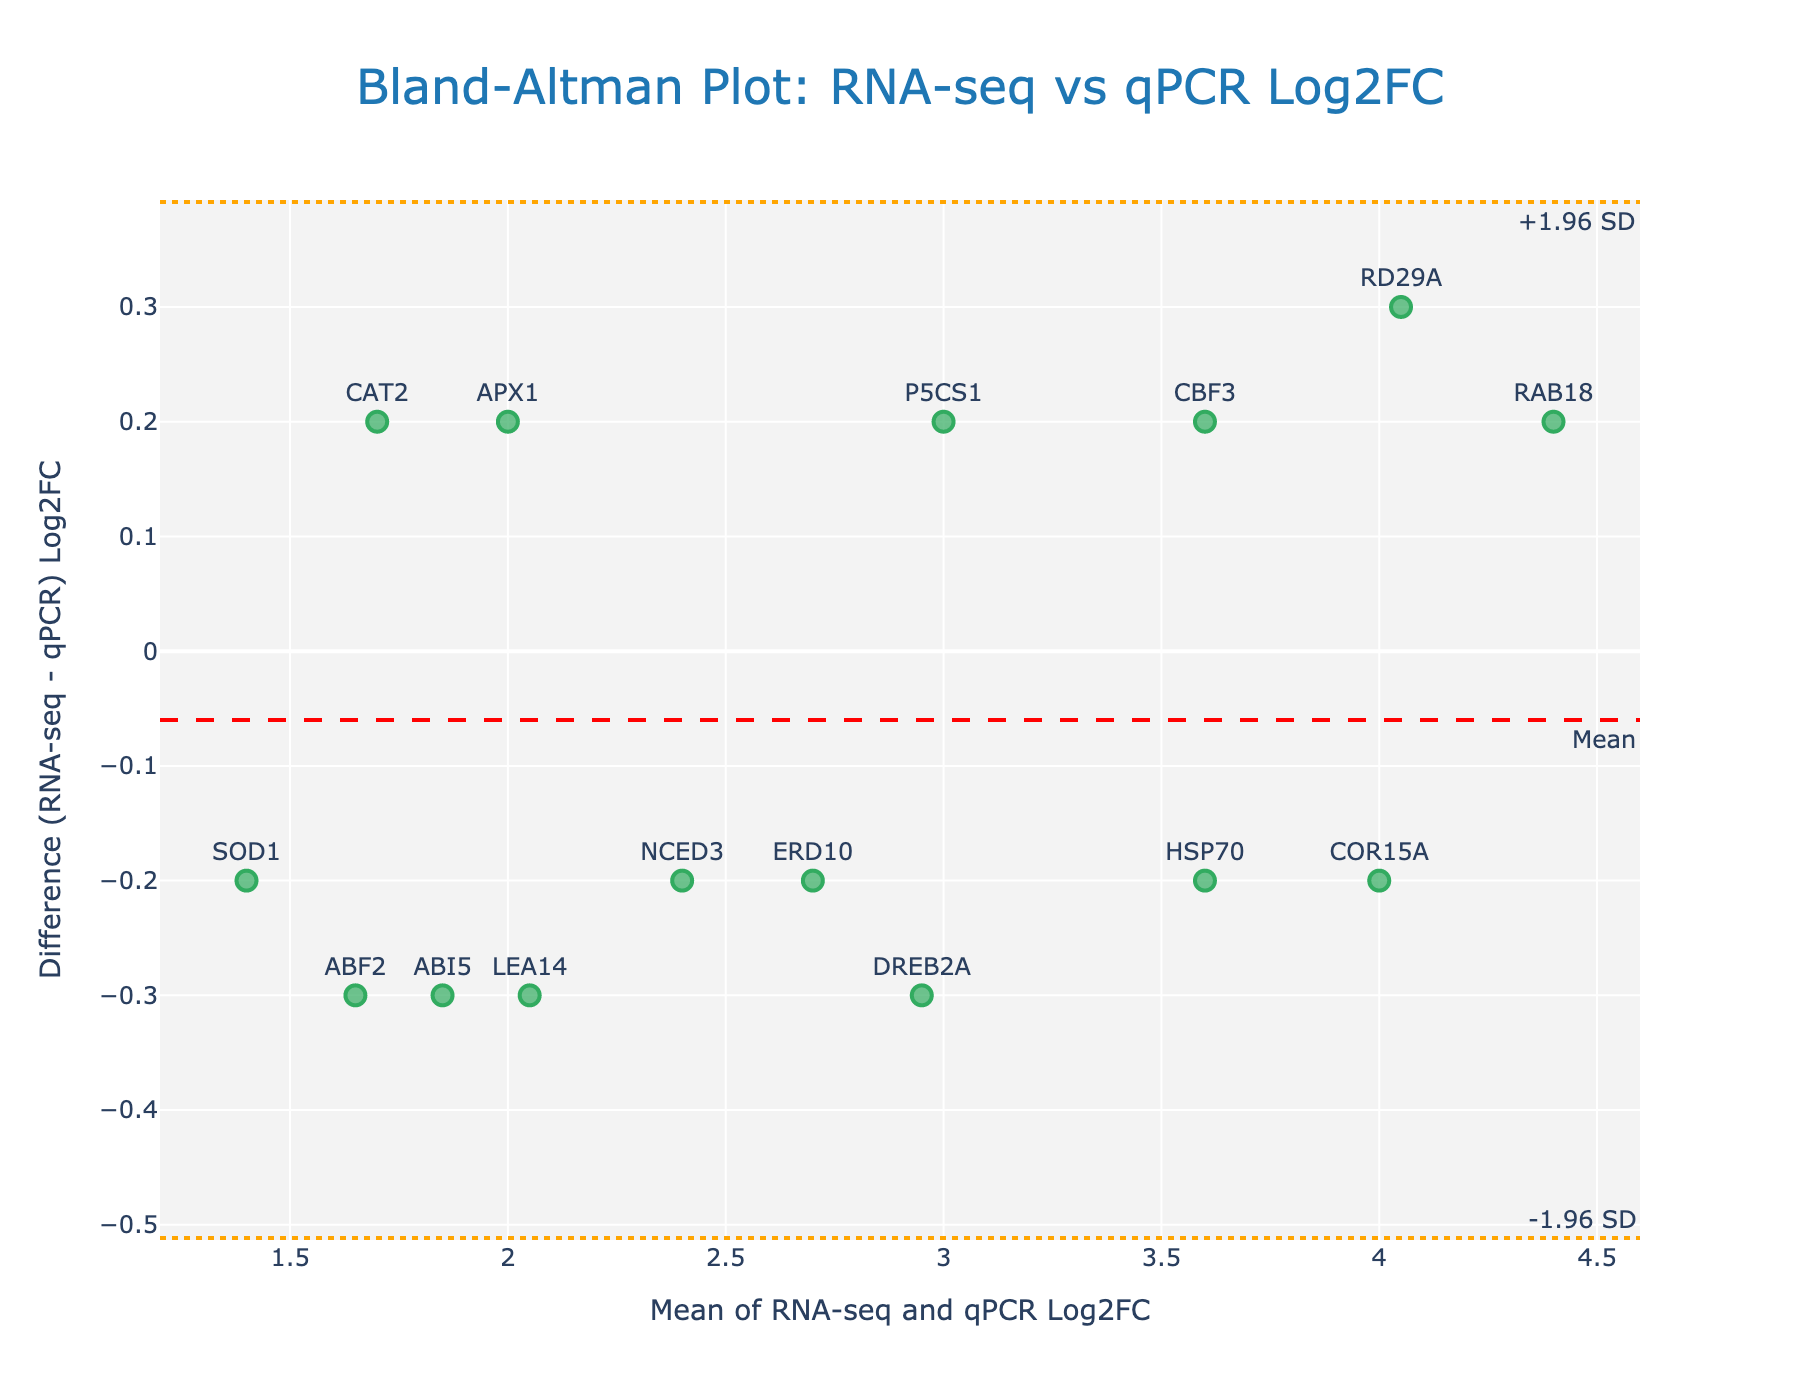What is the title of the plot? The title is usually located at the top of the plot and visually represents the main subject of the figure. Here, it says "Bland-Altman Plot: RNA-seq vs qPCR Log2FC" which provides the context of comparing RNA-seq and qPCR log2 fold changes.
Answer: Bland-Altman Plot: RNA-seq vs qPCR Log2FC How many genes are represented in the plot? To find the number of genes, count the number of markers on the scatter plot. Each marker, labeled with a gene name, represents a different gene.
Answer: 15 What do the orange dashed lines represent? The orange dashed lines are positioned at specific y-values and are annotated as "+1.96 SD" and "-1.96 SD". These lines represent the upper and lower limits of agreement, calculated as mean difference plus and minus 1.96 times the standard deviation of the differences.
Answer: Limits of agreement Which gene shows the greatest positive difference between RNA-seq and qPCR Log2FC? The gene with the greatest positive difference is the one with the highest y-value above the mean difference line. By reviewing the plot, we find that "DREB2A" has the highest positive difference.
Answer: DREB2A What's the mean difference between RNA-seq and qPCR Log2FC? The mean difference is shown by the red dashed line labeled "Mean". This y-value represents the average difference between RNA-seq and qPCR log2 fold changes across all genes.
Answer: approximately 0 Which gene has the least absolute value of difference between RNA-seq and qPCR Log2FC? The gene with the least absolute value of difference is the one closest to the red mean difference line, suggesting minimal discrepancy between RNA-seq and qPCR measurements. By inspecting the plot, "CBF3" appears closest to the mean line.
Answer: CBF3 How many genes fall within the limits of agreement? To determine this, count the number of markers that are between the +1.96 SD and -1.96 SD lines, which represent the limits of agreement.
Answer: 15 Which gene shows the highest Log2FC average between RNA-seq and qPCR? The gene with the highest Log2FC average can be found by identifying the marker farthest to the right on the x-axis. This marker represents the highest mean value of RNA-seq and qPCR log2 fold changes. Here, "RAB18" is the farthest right.
Answer: RAB18 What do the vertical positions of the markers represent in this plot? The vertical positions (y-values) of the markers represent the difference in Log2FC between RNA-seq and qPCR for each gene. A positive value means RNA-seq Log2FC is higher than qPCR Log2FC for that gene, and a negative value means the opposite.
Answer: Difference in Log2FC What does the horizontal position of the marker for gene "LEA14" signify? The horizontal position (x-value) of the marker for "LEA14" represents the average Log2FC of RNA-seq and qPCR values for "LEA14". This is calculated by taking the mean of RNA-seq and qPCR Log2FC values for that gene.
Answer: approximately 2.05 